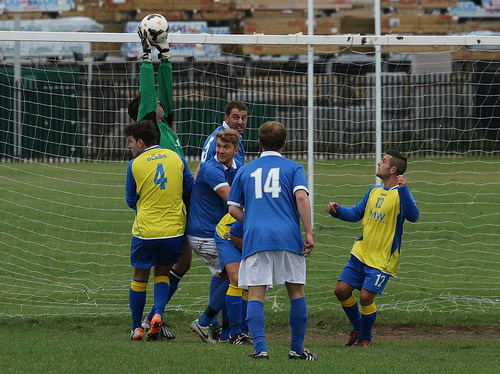<image>
Is the ball to the left of the man? Yes. From this viewpoint, the ball is positioned to the left side relative to the man. 